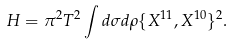<formula> <loc_0><loc_0><loc_500><loc_500>H = \pi ^ { 2 } T ^ { 2 } \int d \sigma d \rho \{ X ^ { 1 1 } , X ^ { 1 0 } \} ^ { 2 } .</formula> 